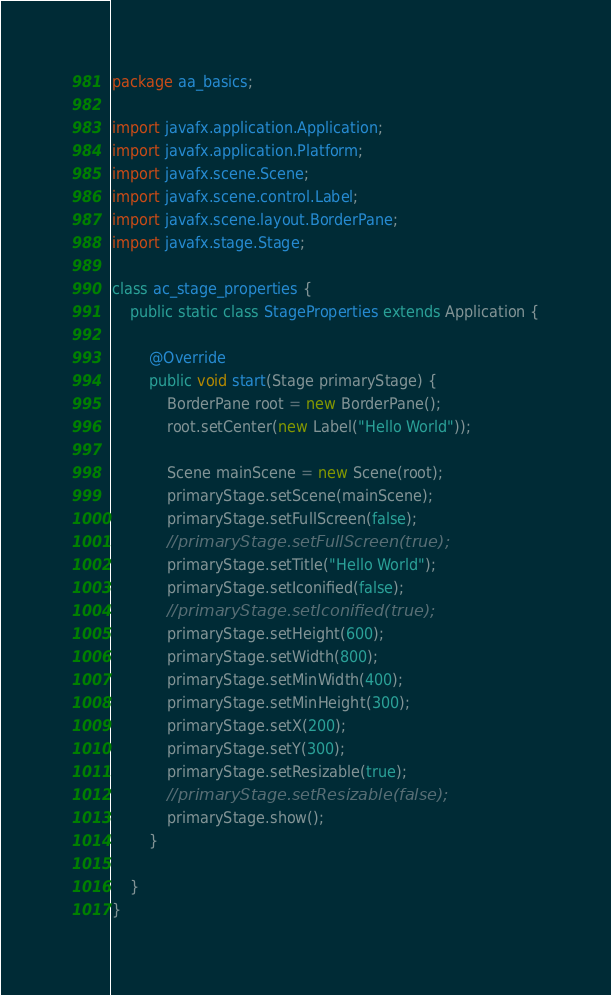<code> <loc_0><loc_0><loc_500><loc_500><_Java_>package aa_basics;

import javafx.application.Application;
import javafx.application.Platform;
import javafx.scene.Scene;
import javafx.scene.control.Label;
import javafx.scene.layout.BorderPane;
import javafx.stage.Stage;

class ac_stage_properties {
    public static class StageProperties extends Application {

        @Override
        public void start(Stage primaryStage) {
            BorderPane root = new BorderPane();
            root.setCenter(new Label("Hello World"));

            Scene mainScene = new Scene(root);
            primaryStage.setScene(mainScene);
            primaryStage.setFullScreen(false);
            //primaryStage.setFullScreen(true);
            primaryStage.setTitle("Hello World");
            primaryStage.setIconified(false);
            //primaryStage.setIconified(true);
            primaryStage.setHeight(600);
            primaryStage.setWidth(800);
            primaryStage.setMinWidth(400);
            primaryStage.setMinHeight(300);
            primaryStage.setX(200);
            primaryStage.setY(300);
            primaryStage.setResizable(true);
            //primaryStage.setResizable(false);
            primaryStage.show();
        }

    }
}
</code> 